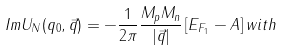<formula> <loc_0><loc_0><loc_500><loc_500>I m { U _ { N } } ( q _ { 0 } , \vec { q } ) = - \frac { 1 } { 2 \pi } \frac { M _ { p } { M _ { n } } } { | \vec { q } | } \left [ E _ { F _ { 1 } } - A \right ] w i t h</formula> 